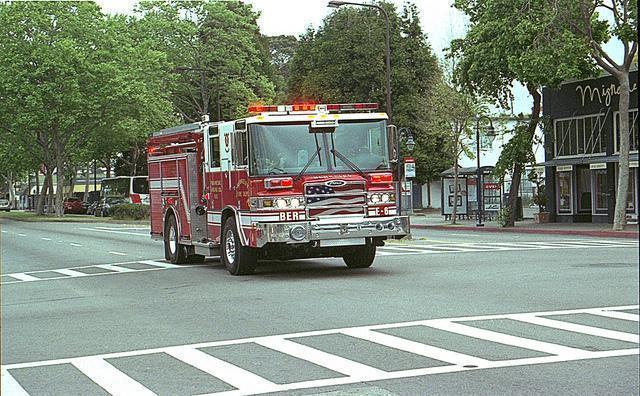What do the flashing lights indicate on this vehicle?
Select the accurate response from the four choices given to answer the question.
Options: Bad weather, fire, crime, parade. Fire. 